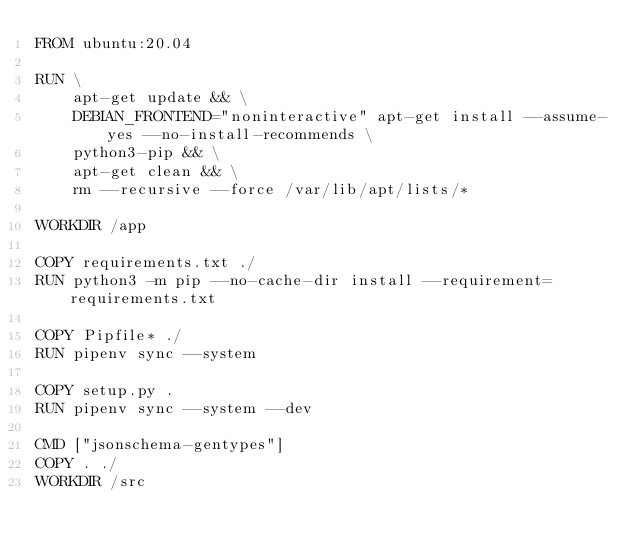Convert code to text. <code><loc_0><loc_0><loc_500><loc_500><_Dockerfile_>FROM ubuntu:20.04

RUN \
    apt-get update && \
    DEBIAN_FRONTEND="noninteractive" apt-get install --assume-yes --no-install-recommends \
    python3-pip && \
    apt-get clean && \
    rm --recursive --force /var/lib/apt/lists/*

WORKDIR /app

COPY requirements.txt ./
RUN python3 -m pip --no-cache-dir install --requirement=requirements.txt

COPY Pipfile* ./
RUN	pipenv sync --system

COPY setup.py .
RUN	pipenv sync --system --dev

CMD ["jsonschema-gentypes"]
COPY . ./
WORKDIR /src
</code> 